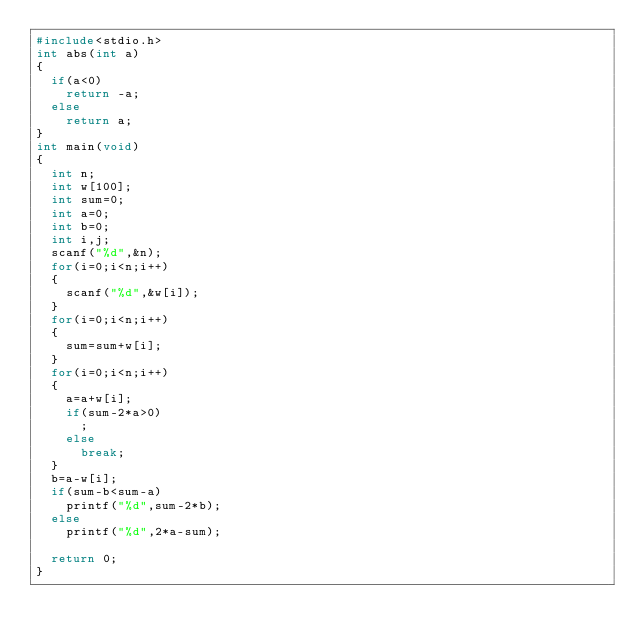<code> <loc_0><loc_0><loc_500><loc_500><_C_>#include<stdio.h>
int abs(int a)
{
  if(a<0)
    return -a;
  else
    return a;
}
int main(void)
{
  int n;
  int w[100];
  int sum=0;
  int a=0;
  int b=0;
  int i,j;
  scanf("%d",&n);
  for(i=0;i<n;i++)
  {
    scanf("%d",&w[i]);
  }
  for(i=0;i<n;i++)
  {
    sum=sum+w[i];
  }
  for(i=0;i<n;i++)
  {
    a=a+w[i];
    if(sum-2*a>0)
      ;
    else
      break;
  }
  b=a-w[i];
  if(sum-b<sum-a)
    printf("%d",sum-2*b);
  else
    printf("%d",2*a-sum);
  
  return 0;
}</code> 